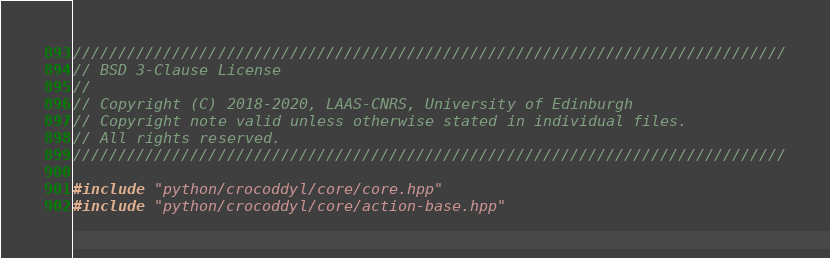<code> <loc_0><loc_0><loc_500><loc_500><_C++_>///////////////////////////////////////////////////////////////////////////////
// BSD 3-Clause License
//
// Copyright (C) 2018-2020, LAAS-CNRS, University of Edinburgh
// Copyright note valid unless otherwise stated in individual files.
// All rights reserved.
///////////////////////////////////////////////////////////////////////////////

#include "python/crocoddyl/core/core.hpp"
#include "python/crocoddyl/core/action-base.hpp"</code> 